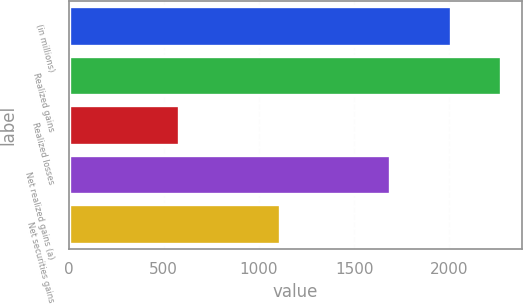Convert chart. <chart><loc_0><loc_0><loc_500><loc_500><bar_chart><fcel>(in millions)<fcel>Realized gains<fcel>Realized losses<fcel>Net realized gains (a)<fcel>Net securities gains<nl><fcel>2009<fcel>2268<fcel>580<fcel>1688<fcel>1110<nl></chart> 